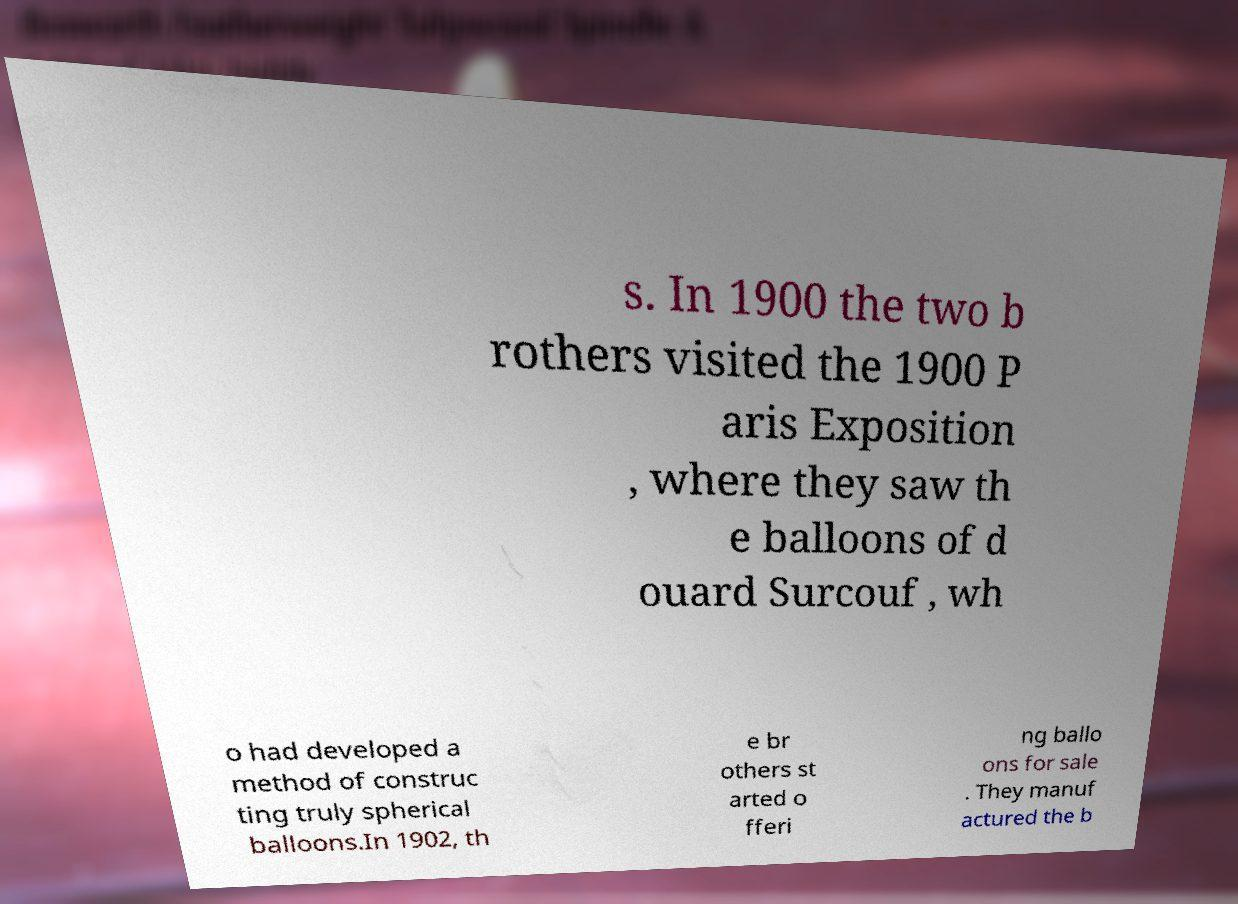Could you assist in decoding the text presented in this image and type it out clearly? s. In 1900 the two b rothers visited the 1900 P aris Exposition , where they saw th e balloons of d ouard Surcouf , wh o had developed a method of construc ting truly spherical balloons.In 1902, th e br others st arted o fferi ng ballo ons for sale . They manuf actured the b 